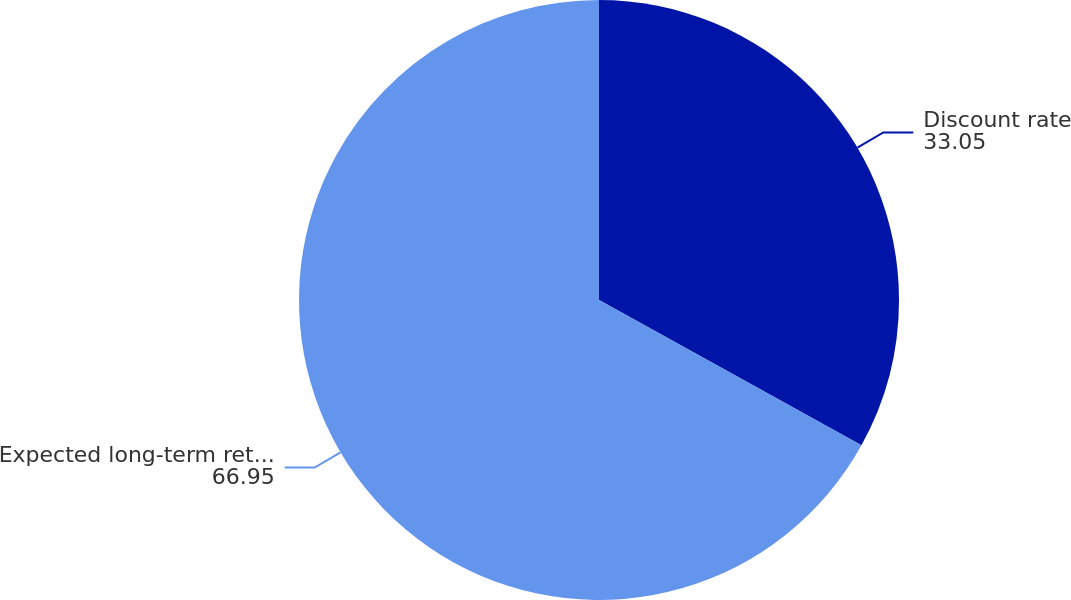Convert chart to OTSL. <chart><loc_0><loc_0><loc_500><loc_500><pie_chart><fcel>Discount rate<fcel>Expected long-term return on<nl><fcel>33.05%<fcel>66.95%<nl></chart> 